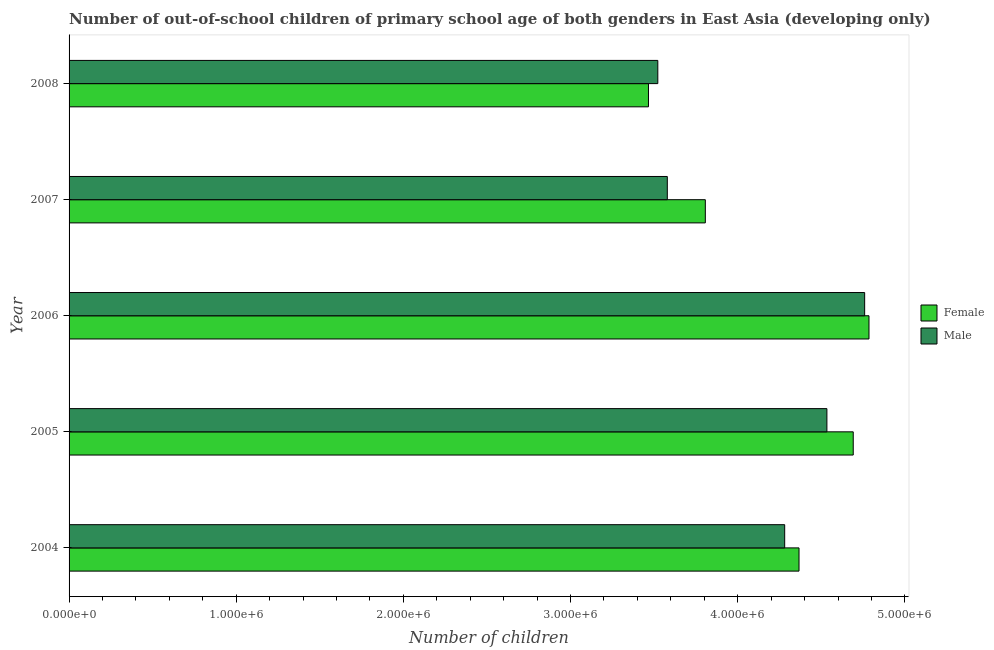How many different coloured bars are there?
Ensure brevity in your answer.  2. Are the number of bars per tick equal to the number of legend labels?
Give a very brief answer. Yes. Are the number of bars on each tick of the Y-axis equal?
Keep it short and to the point. Yes. How many bars are there on the 5th tick from the bottom?
Give a very brief answer. 2. What is the number of male out-of-school students in 2006?
Keep it short and to the point. 4.76e+06. Across all years, what is the maximum number of female out-of-school students?
Ensure brevity in your answer.  4.79e+06. Across all years, what is the minimum number of female out-of-school students?
Provide a short and direct response. 3.47e+06. In which year was the number of female out-of-school students minimum?
Offer a terse response. 2008. What is the total number of male out-of-school students in the graph?
Offer a terse response. 2.07e+07. What is the difference between the number of male out-of-school students in 2006 and that in 2008?
Make the answer very short. 1.24e+06. What is the difference between the number of female out-of-school students in 2006 and the number of male out-of-school students in 2007?
Provide a short and direct response. 1.21e+06. What is the average number of female out-of-school students per year?
Provide a succinct answer. 4.22e+06. In the year 2004, what is the difference between the number of male out-of-school students and number of female out-of-school students?
Your answer should be very brief. -8.57e+04. In how many years, is the number of female out-of-school students greater than 200000 ?
Your answer should be very brief. 5. What is the ratio of the number of female out-of-school students in 2004 to that in 2006?
Provide a short and direct response. 0.91. Is the number of female out-of-school students in 2006 less than that in 2007?
Your answer should be very brief. No. Is the difference between the number of male out-of-school students in 2006 and 2008 greater than the difference between the number of female out-of-school students in 2006 and 2008?
Keep it short and to the point. No. What is the difference between the highest and the second highest number of female out-of-school students?
Your response must be concise. 9.42e+04. What is the difference between the highest and the lowest number of female out-of-school students?
Keep it short and to the point. 1.32e+06. What does the 1st bar from the top in 2005 represents?
Make the answer very short. Male. How many bars are there?
Provide a short and direct response. 10. Are all the bars in the graph horizontal?
Keep it short and to the point. Yes. What is the difference between two consecutive major ticks on the X-axis?
Ensure brevity in your answer.  1.00e+06. Where does the legend appear in the graph?
Make the answer very short. Center right. What is the title of the graph?
Keep it short and to the point. Number of out-of-school children of primary school age of both genders in East Asia (developing only). What is the label or title of the X-axis?
Your answer should be very brief. Number of children. What is the label or title of the Y-axis?
Keep it short and to the point. Year. What is the Number of children of Female in 2004?
Give a very brief answer. 4.37e+06. What is the Number of children of Male in 2004?
Give a very brief answer. 4.28e+06. What is the Number of children in Female in 2005?
Offer a terse response. 4.69e+06. What is the Number of children of Male in 2005?
Keep it short and to the point. 4.53e+06. What is the Number of children in Female in 2006?
Ensure brevity in your answer.  4.79e+06. What is the Number of children of Male in 2006?
Provide a succinct answer. 4.76e+06. What is the Number of children in Female in 2007?
Provide a succinct answer. 3.81e+06. What is the Number of children in Male in 2007?
Offer a terse response. 3.58e+06. What is the Number of children in Female in 2008?
Ensure brevity in your answer.  3.47e+06. What is the Number of children in Male in 2008?
Offer a terse response. 3.52e+06. Across all years, what is the maximum Number of children in Female?
Ensure brevity in your answer.  4.79e+06. Across all years, what is the maximum Number of children in Male?
Keep it short and to the point. 4.76e+06. Across all years, what is the minimum Number of children of Female?
Provide a succinct answer. 3.47e+06. Across all years, what is the minimum Number of children in Male?
Provide a short and direct response. 3.52e+06. What is the total Number of children of Female in the graph?
Your answer should be compact. 2.11e+07. What is the total Number of children of Male in the graph?
Ensure brevity in your answer.  2.07e+07. What is the difference between the Number of children in Female in 2004 and that in 2005?
Your response must be concise. -3.24e+05. What is the difference between the Number of children in Male in 2004 and that in 2005?
Your answer should be compact. -2.53e+05. What is the difference between the Number of children of Female in 2004 and that in 2006?
Provide a short and direct response. -4.19e+05. What is the difference between the Number of children of Male in 2004 and that in 2006?
Your response must be concise. -4.78e+05. What is the difference between the Number of children of Female in 2004 and that in 2007?
Ensure brevity in your answer.  5.61e+05. What is the difference between the Number of children of Male in 2004 and that in 2007?
Offer a terse response. 7.02e+05. What is the difference between the Number of children of Female in 2004 and that in 2008?
Your response must be concise. 9.01e+05. What is the difference between the Number of children in Male in 2004 and that in 2008?
Provide a succinct answer. 7.59e+05. What is the difference between the Number of children of Female in 2005 and that in 2006?
Your answer should be compact. -9.42e+04. What is the difference between the Number of children in Male in 2005 and that in 2006?
Your answer should be compact. -2.26e+05. What is the difference between the Number of children of Female in 2005 and that in 2007?
Your answer should be very brief. 8.85e+05. What is the difference between the Number of children in Male in 2005 and that in 2007?
Provide a succinct answer. 9.55e+05. What is the difference between the Number of children of Female in 2005 and that in 2008?
Your answer should be very brief. 1.22e+06. What is the difference between the Number of children of Male in 2005 and that in 2008?
Your answer should be compact. 1.01e+06. What is the difference between the Number of children in Female in 2006 and that in 2007?
Keep it short and to the point. 9.79e+05. What is the difference between the Number of children of Male in 2006 and that in 2007?
Offer a terse response. 1.18e+06. What is the difference between the Number of children in Female in 2006 and that in 2008?
Keep it short and to the point. 1.32e+06. What is the difference between the Number of children in Male in 2006 and that in 2008?
Keep it short and to the point. 1.24e+06. What is the difference between the Number of children of Female in 2007 and that in 2008?
Offer a terse response. 3.40e+05. What is the difference between the Number of children of Male in 2007 and that in 2008?
Give a very brief answer. 5.68e+04. What is the difference between the Number of children of Female in 2004 and the Number of children of Male in 2005?
Your answer should be compact. -1.67e+05. What is the difference between the Number of children in Female in 2004 and the Number of children in Male in 2006?
Offer a terse response. -3.93e+05. What is the difference between the Number of children of Female in 2004 and the Number of children of Male in 2007?
Keep it short and to the point. 7.88e+05. What is the difference between the Number of children in Female in 2004 and the Number of children in Male in 2008?
Your answer should be compact. 8.45e+05. What is the difference between the Number of children of Female in 2005 and the Number of children of Male in 2006?
Give a very brief answer. -6.84e+04. What is the difference between the Number of children of Female in 2005 and the Number of children of Male in 2007?
Your response must be concise. 1.11e+06. What is the difference between the Number of children of Female in 2005 and the Number of children of Male in 2008?
Make the answer very short. 1.17e+06. What is the difference between the Number of children of Female in 2006 and the Number of children of Male in 2007?
Your answer should be compact. 1.21e+06. What is the difference between the Number of children of Female in 2006 and the Number of children of Male in 2008?
Your answer should be very brief. 1.26e+06. What is the difference between the Number of children in Female in 2007 and the Number of children in Male in 2008?
Offer a very short reply. 2.84e+05. What is the average Number of children of Female per year?
Your response must be concise. 4.22e+06. What is the average Number of children of Male per year?
Provide a succinct answer. 4.13e+06. In the year 2004, what is the difference between the Number of children of Female and Number of children of Male?
Keep it short and to the point. 8.57e+04. In the year 2005, what is the difference between the Number of children in Female and Number of children in Male?
Provide a short and direct response. 1.57e+05. In the year 2006, what is the difference between the Number of children in Female and Number of children in Male?
Keep it short and to the point. 2.58e+04. In the year 2007, what is the difference between the Number of children in Female and Number of children in Male?
Provide a succinct answer. 2.27e+05. In the year 2008, what is the difference between the Number of children of Female and Number of children of Male?
Provide a succinct answer. -5.59e+04. What is the ratio of the Number of children of Female in 2004 to that in 2005?
Ensure brevity in your answer.  0.93. What is the ratio of the Number of children in Male in 2004 to that in 2005?
Your response must be concise. 0.94. What is the ratio of the Number of children of Female in 2004 to that in 2006?
Ensure brevity in your answer.  0.91. What is the ratio of the Number of children in Male in 2004 to that in 2006?
Your answer should be compact. 0.9. What is the ratio of the Number of children in Female in 2004 to that in 2007?
Provide a succinct answer. 1.15. What is the ratio of the Number of children of Male in 2004 to that in 2007?
Give a very brief answer. 1.2. What is the ratio of the Number of children in Female in 2004 to that in 2008?
Your answer should be very brief. 1.26. What is the ratio of the Number of children in Male in 2004 to that in 2008?
Offer a very short reply. 1.22. What is the ratio of the Number of children of Female in 2005 to that in 2006?
Offer a terse response. 0.98. What is the ratio of the Number of children of Male in 2005 to that in 2006?
Provide a short and direct response. 0.95. What is the ratio of the Number of children of Female in 2005 to that in 2007?
Your response must be concise. 1.23. What is the ratio of the Number of children in Male in 2005 to that in 2007?
Provide a short and direct response. 1.27. What is the ratio of the Number of children in Female in 2005 to that in 2008?
Offer a very short reply. 1.35. What is the ratio of the Number of children of Male in 2005 to that in 2008?
Ensure brevity in your answer.  1.29. What is the ratio of the Number of children of Female in 2006 to that in 2007?
Make the answer very short. 1.26. What is the ratio of the Number of children of Male in 2006 to that in 2007?
Keep it short and to the point. 1.33. What is the ratio of the Number of children of Female in 2006 to that in 2008?
Provide a short and direct response. 1.38. What is the ratio of the Number of children in Male in 2006 to that in 2008?
Provide a succinct answer. 1.35. What is the ratio of the Number of children in Female in 2007 to that in 2008?
Provide a short and direct response. 1.1. What is the ratio of the Number of children in Male in 2007 to that in 2008?
Your answer should be very brief. 1.02. What is the difference between the highest and the second highest Number of children in Female?
Offer a very short reply. 9.42e+04. What is the difference between the highest and the second highest Number of children in Male?
Make the answer very short. 2.26e+05. What is the difference between the highest and the lowest Number of children in Female?
Ensure brevity in your answer.  1.32e+06. What is the difference between the highest and the lowest Number of children of Male?
Provide a succinct answer. 1.24e+06. 